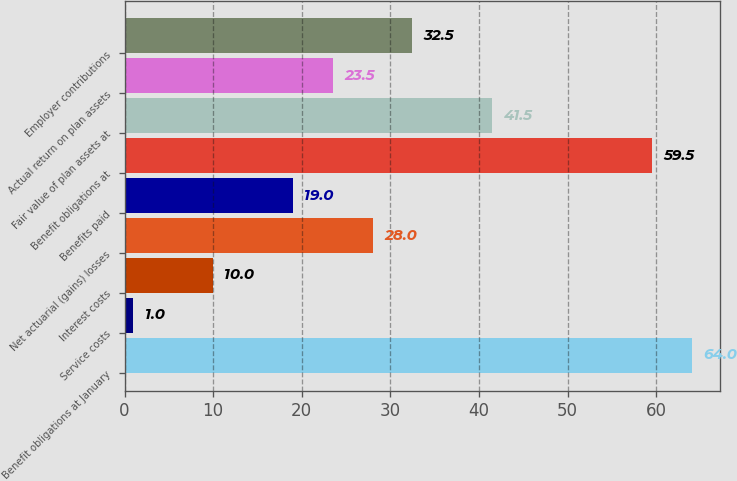Convert chart to OTSL. <chart><loc_0><loc_0><loc_500><loc_500><bar_chart><fcel>Benefit obligations at January<fcel>Service costs<fcel>Interest costs<fcel>Net actuarial (gains) losses<fcel>Benefits paid<fcel>Benefit obligations at<fcel>Fair value of plan assets at<fcel>Actual return on plan assets<fcel>Employer contributions<nl><fcel>64<fcel>1<fcel>10<fcel>28<fcel>19<fcel>59.5<fcel>41.5<fcel>23.5<fcel>32.5<nl></chart> 